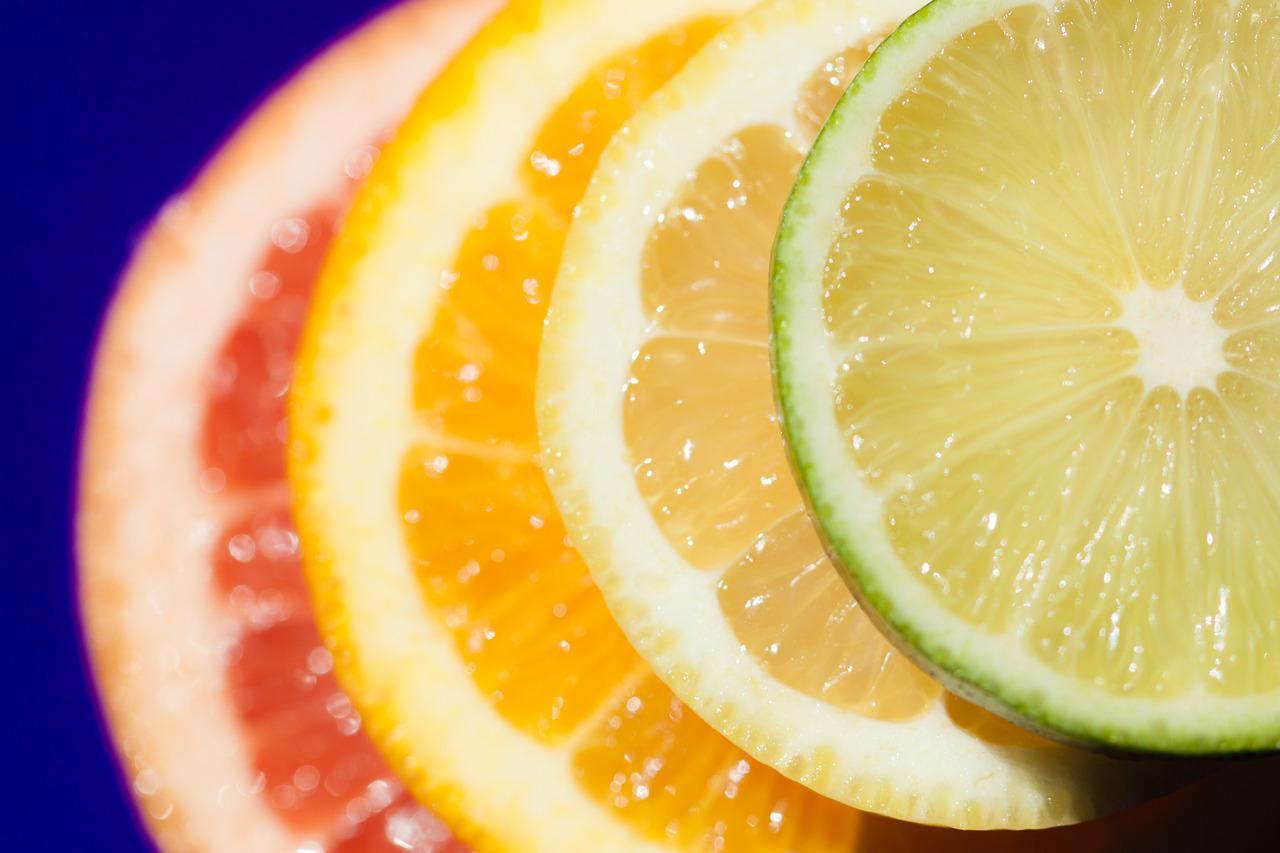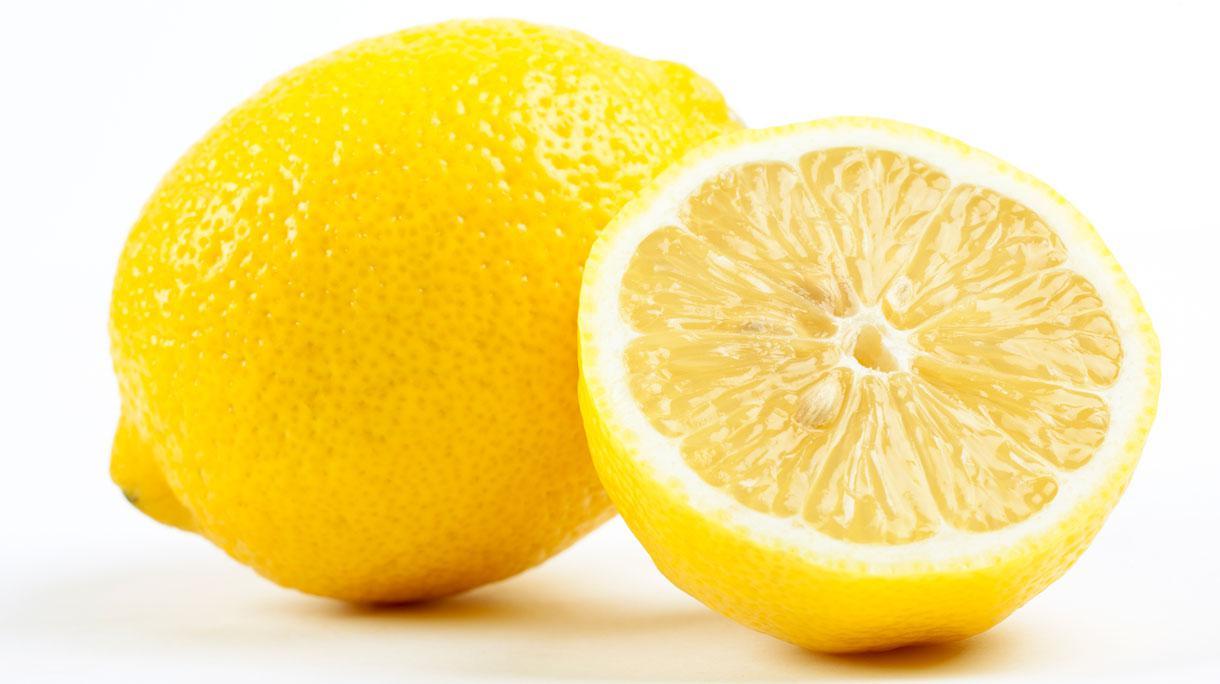The first image is the image on the left, the second image is the image on the right. Given the left and right images, does the statement "In at least one image there are at least four different types of citrus fruit." hold true? Answer yes or no. Yes. The first image is the image on the left, the second image is the image on the right. For the images shown, is this caption "The right image contains three lemons, one of which has been cut in half." true? Answer yes or no. No. 